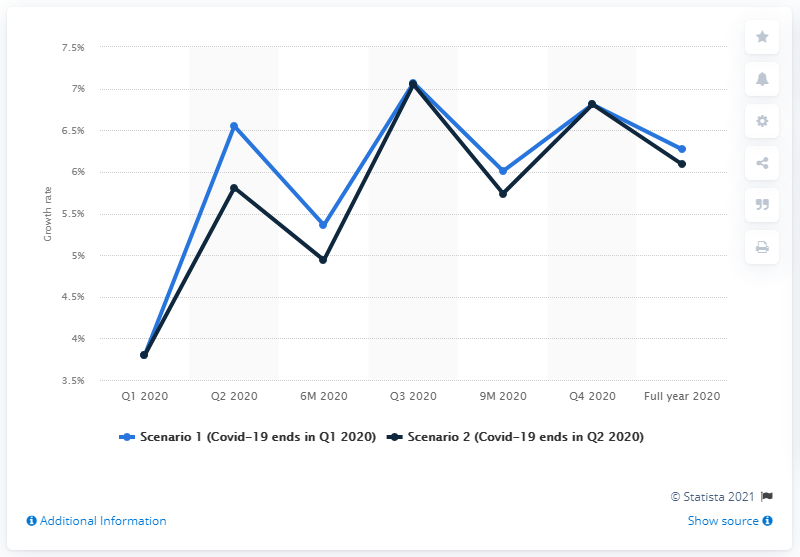Outline some significant characteristics in this image. Prior to the COVID-19 pandemic, the initial projections for the growth of the Gross Domestic Product (GDP) were 6.81%. The projection for the second quarter of 2020 was that the GDP would increase by 6.09%. 